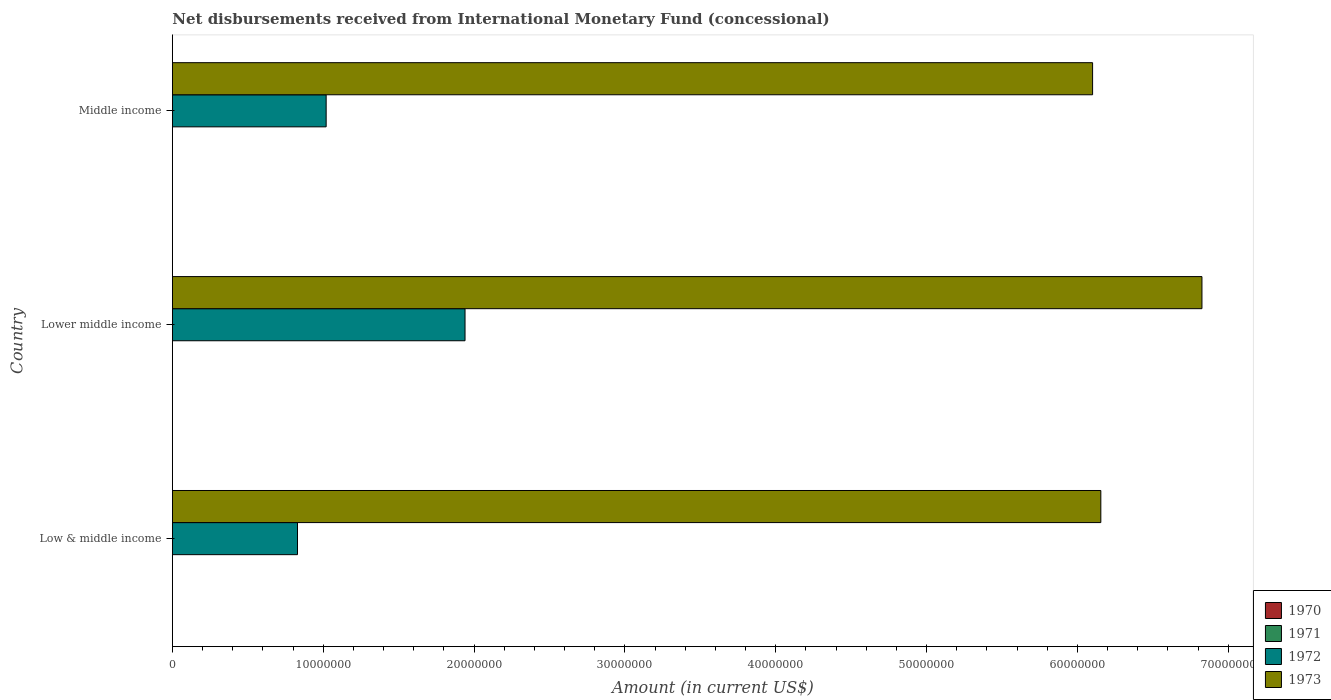Are the number of bars per tick equal to the number of legend labels?
Give a very brief answer. No. Are the number of bars on each tick of the Y-axis equal?
Keep it short and to the point. Yes. How many bars are there on the 2nd tick from the top?
Make the answer very short. 2. How many bars are there on the 3rd tick from the bottom?
Your answer should be very brief. 2. What is the label of the 3rd group of bars from the top?
Offer a terse response. Low & middle income. Across all countries, what is the maximum amount of disbursements received from International Monetary Fund in 1973?
Your answer should be compact. 6.83e+07. In which country was the amount of disbursements received from International Monetary Fund in 1972 maximum?
Give a very brief answer. Lower middle income. What is the total amount of disbursements received from International Monetary Fund in 1972 in the graph?
Offer a terse response. 3.79e+07. What is the difference between the amount of disbursements received from International Monetary Fund in 1973 in Low & middle income and that in Middle income?
Your answer should be very brief. 5.46e+05. What is the difference between the amount of disbursements received from International Monetary Fund in 1973 in Middle income and the amount of disbursements received from International Monetary Fund in 1972 in Low & middle income?
Offer a very short reply. 5.27e+07. What is the difference between the amount of disbursements received from International Monetary Fund in 1972 and amount of disbursements received from International Monetary Fund in 1973 in Low & middle income?
Your answer should be compact. -5.33e+07. In how many countries, is the amount of disbursements received from International Monetary Fund in 1971 greater than 10000000 US$?
Ensure brevity in your answer.  0. What is the ratio of the amount of disbursements received from International Monetary Fund in 1972 in Low & middle income to that in Lower middle income?
Offer a terse response. 0.43. What is the difference between the highest and the second highest amount of disbursements received from International Monetary Fund in 1972?
Provide a short and direct response. 9.21e+06. What is the difference between the highest and the lowest amount of disbursements received from International Monetary Fund in 1972?
Give a very brief answer. 1.11e+07. In how many countries, is the amount of disbursements received from International Monetary Fund in 1972 greater than the average amount of disbursements received from International Monetary Fund in 1972 taken over all countries?
Keep it short and to the point. 1. Is the sum of the amount of disbursements received from International Monetary Fund in 1972 in Low & middle income and Middle income greater than the maximum amount of disbursements received from International Monetary Fund in 1970 across all countries?
Offer a very short reply. Yes. Is it the case that in every country, the sum of the amount of disbursements received from International Monetary Fund in 1971 and amount of disbursements received from International Monetary Fund in 1972 is greater than the amount of disbursements received from International Monetary Fund in 1973?
Provide a short and direct response. No. How many bars are there?
Offer a very short reply. 6. What is the difference between two consecutive major ticks on the X-axis?
Your response must be concise. 1.00e+07. Does the graph contain any zero values?
Provide a succinct answer. Yes. Does the graph contain grids?
Offer a terse response. No. How are the legend labels stacked?
Offer a terse response. Vertical. What is the title of the graph?
Your answer should be very brief. Net disbursements received from International Monetary Fund (concessional). What is the label or title of the X-axis?
Provide a succinct answer. Amount (in current US$). What is the label or title of the Y-axis?
Keep it short and to the point. Country. What is the Amount (in current US$) in 1971 in Low & middle income?
Ensure brevity in your answer.  0. What is the Amount (in current US$) in 1972 in Low & middle income?
Offer a terse response. 8.30e+06. What is the Amount (in current US$) in 1973 in Low & middle income?
Offer a terse response. 6.16e+07. What is the Amount (in current US$) of 1970 in Lower middle income?
Ensure brevity in your answer.  0. What is the Amount (in current US$) in 1971 in Lower middle income?
Your answer should be very brief. 0. What is the Amount (in current US$) in 1972 in Lower middle income?
Your response must be concise. 1.94e+07. What is the Amount (in current US$) in 1973 in Lower middle income?
Provide a succinct answer. 6.83e+07. What is the Amount (in current US$) in 1970 in Middle income?
Keep it short and to the point. 0. What is the Amount (in current US$) of 1972 in Middle income?
Your answer should be compact. 1.02e+07. What is the Amount (in current US$) of 1973 in Middle income?
Your answer should be compact. 6.10e+07. Across all countries, what is the maximum Amount (in current US$) in 1972?
Provide a short and direct response. 1.94e+07. Across all countries, what is the maximum Amount (in current US$) of 1973?
Your answer should be very brief. 6.83e+07. Across all countries, what is the minimum Amount (in current US$) in 1972?
Offer a very short reply. 8.30e+06. Across all countries, what is the minimum Amount (in current US$) of 1973?
Give a very brief answer. 6.10e+07. What is the total Amount (in current US$) in 1970 in the graph?
Your answer should be very brief. 0. What is the total Amount (in current US$) of 1972 in the graph?
Keep it short and to the point. 3.79e+07. What is the total Amount (in current US$) in 1973 in the graph?
Your response must be concise. 1.91e+08. What is the difference between the Amount (in current US$) of 1972 in Low & middle income and that in Lower middle income?
Provide a short and direct response. -1.11e+07. What is the difference between the Amount (in current US$) of 1973 in Low & middle income and that in Lower middle income?
Provide a succinct answer. -6.70e+06. What is the difference between the Amount (in current US$) in 1972 in Low & middle income and that in Middle income?
Offer a very short reply. -1.90e+06. What is the difference between the Amount (in current US$) of 1973 in Low & middle income and that in Middle income?
Give a very brief answer. 5.46e+05. What is the difference between the Amount (in current US$) of 1972 in Lower middle income and that in Middle income?
Your answer should be compact. 9.21e+06. What is the difference between the Amount (in current US$) of 1973 in Lower middle income and that in Middle income?
Offer a terse response. 7.25e+06. What is the difference between the Amount (in current US$) of 1972 in Low & middle income and the Amount (in current US$) of 1973 in Lower middle income?
Provide a short and direct response. -6.00e+07. What is the difference between the Amount (in current US$) of 1972 in Low & middle income and the Amount (in current US$) of 1973 in Middle income?
Your answer should be very brief. -5.27e+07. What is the difference between the Amount (in current US$) in 1972 in Lower middle income and the Amount (in current US$) in 1973 in Middle income?
Your answer should be compact. -4.16e+07. What is the average Amount (in current US$) in 1970 per country?
Your response must be concise. 0. What is the average Amount (in current US$) of 1971 per country?
Give a very brief answer. 0. What is the average Amount (in current US$) of 1972 per country?
Make the answer very short. 1.26e+07. What is the average Amount (in current US$) in 1973 per country?
Your answer should be very brief. 6.36e+07. What is the difference between the Amount (in current US$) in 1972 and Amount (in current US$) in 1973 in Low & middle income?
Provide a succinct answer. -5.33e+07. What is the difference between the Amount (in current US$) of 1972 and Amount (in current US$) of 1973 in Lower middle income?
Provide a short and direct response. -4.89e+07. What is the difference between the Amount (in current US$) in 1972 and Amount (in current US$) in 1973 in Middle income?
Offer a very short reply. -5.08e+07. What is the ratio of the Amount (in current US$) of 1972 in Low & middle income to that in Lower middle income?
Your response must be concise. 0.43. What is the ratio of the Amount (in current US$) of 1973 in Low & middle income to that in Lower middle income?
Make the answer very short. 0.9. What is the ratio of the Amount (in current US$) in 1972 in Low & middle income to that in Middle income?
Your answer should be very brief. 0.81. What is the ratio of the Amount (in current US$) of 1973 in Low & middle income to that in Middle income?
Your response must be concise. 1.01. What is the ratio of the Amount (in current US$) in 1972 in Lower middle income to that in Middle income?
Make the answer very short. 1.9. What is the ratio of the Amount (in current US$) in 1973 in Lower middle income to that in Middle income?
Ensure brevity in your answer.  1.12. What is the difference between the highest and the second highest Amount (in current US$) of 1972?
Keep it short and to the point. 9.21e+06. What is the difference between the highest and the second highest Amount (in current US$) of 1973?
Provide a short and direct response. 6.70e+06. What is the difference between the highest and the lowest Amount (in current US$) of 1972?
Give a very brief answer. 1.11e+07. What is the difference between the highest and the lowest Amount (in current US$) of 1973?
Your answer should be compact. 7.25e+06. 